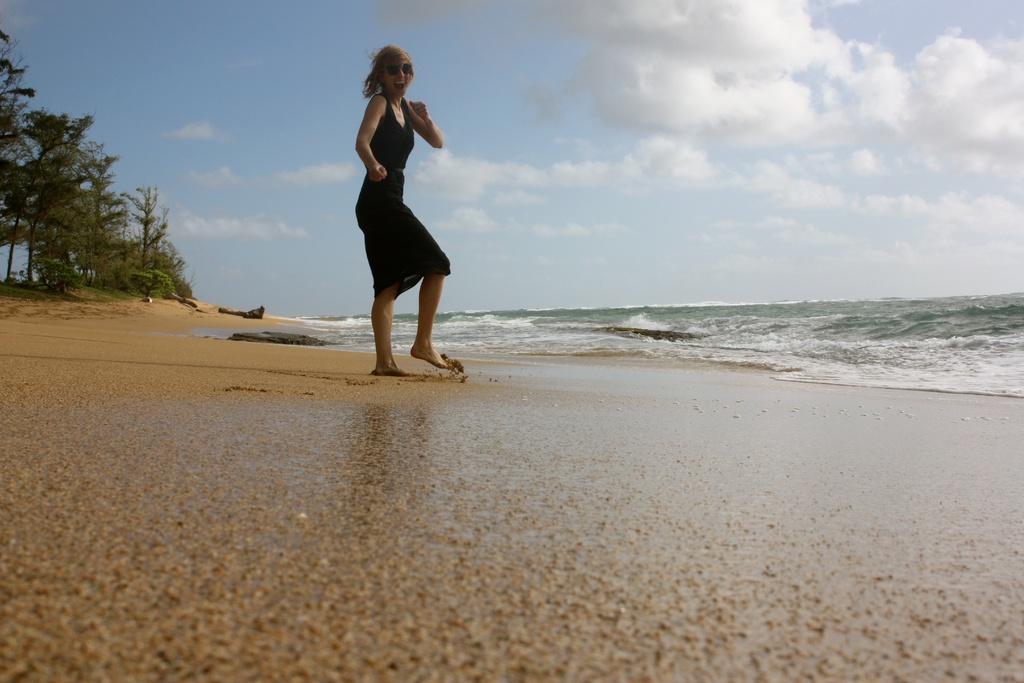Can you describe this image briefly? In this image, we can see a woman standing, at the right side there is water and at the left side there are some green color trees, at the top there is a sky which is cloudy. 